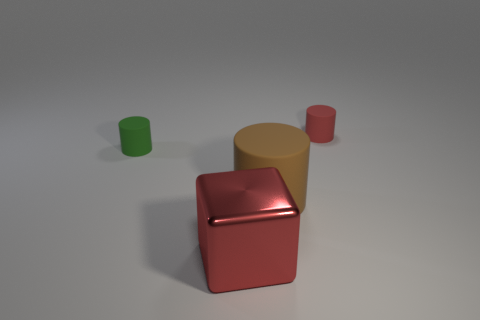What does this arrangement of objects suggest about their use? The arrangement of objects doesn't seem to suggest a practical use but rather an aesthetic or demonstration purpose. The contrasting colors and shapes, alongside their isolated placement, could indicate a display for showcasing the objects' design features or a composition exercise in a photography or art project. 